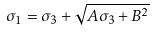Convert formula to latex. <formula><loc_0><loc_0><loc_500><loc_500>\sigma _ { 1 } = \sigma _ { 3 } + \sqrt { A \sigma _ { 3 } + B ^ { 2 } }</formula> 